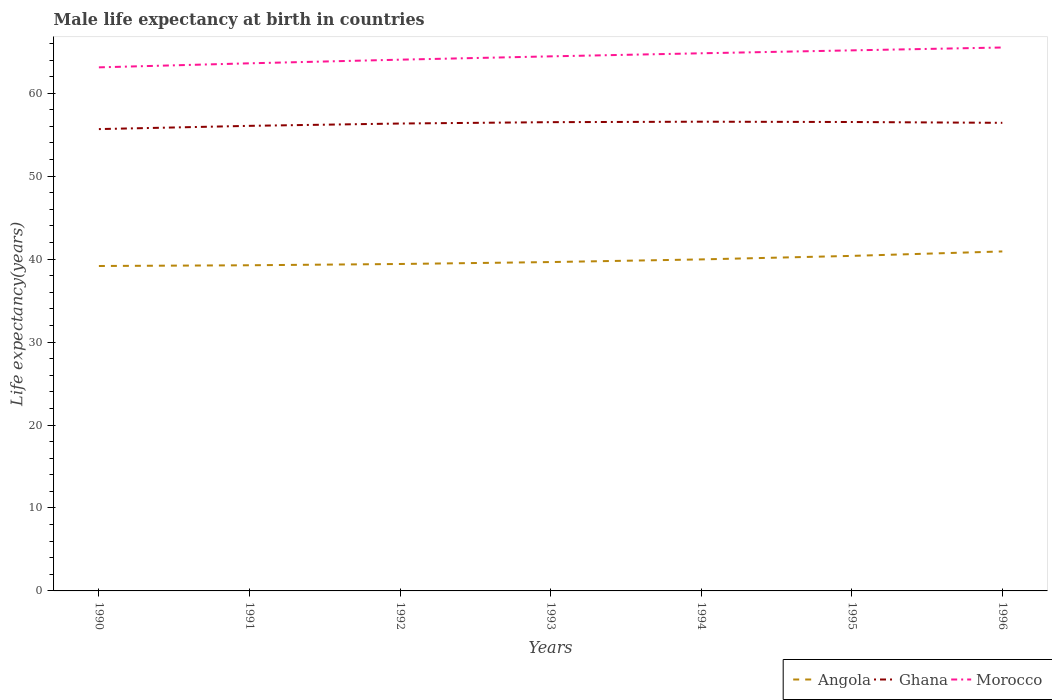Across all years, what is the maximum male life expectancy at birth in Ghana?
Ensure brevity in your answer.  55.68. In which year was the male life expectancy at birth in Ghana maximum?
Your response must be concise. 1990. What is the total male life expectancy at birth in Morocco in the graph?
Make the answer very short. -2.05. What is the difference between the highest and the second highest male life expectancy at birth in Ghana?
Keep it short and to the point. 0.89. Is the male life expectancy at birth in Morocco strictly greater than the male life expectancy at birth in Angola over the years?
Offer a terse response. No. How many years are there in the graph?
Make the answer very short. 7. What is the difference between two consecutive major ticks on the Y-axis?
Keep it short and to the point. 10. Does the graph contain grids?
Give a very brief answer. No. What is the title of the graph?
Offer a terse response. Male life expectancy at birth in countries. Does "Liberia" appear as one of the legend labels in the graph?
Give a very brief answer. No. What is the label or title of the X-axis?
Offer a very short reply. Years. What is the label or title of the Y-axis?
Your response must be concise. Life expectancy(years). What is the Life expectancy(years) in Angola in 1990?
Your answer should be very brief. 39.17. What is the Life expectancy(years) in Ghana in 1990?
Give a very brief answer. 55.68. What is the Life expectancy(years) of Morocco in 1990?
Provide a short and direct response. 63.12. What is the Life expectancy(years) in Angola in 1991?
Ensure brevity in your answer.  39.26. What is the Life expectancy(years) in Ghana in 1991?
Provide a succinct answer. 56.07. What is the Life expectancy(years) in Morocco in 1991?
Your response must be concise. 63.61. What is the Life expectancy(years) in Angola in 1992?
Your answer should be very brief. 39.41. What is the Life expectancy(years) in Ghana in 1992?
Your response must be concise. 56.35. What is the Life expectancy(years) of Morocco in 1992?
Make the answer very short. 64.05. What is the Life expectancy(years) of Angola in 1993?
Make the answer very short. 39.65. What is the Life expectancy(years) in Ghana in 1993?
Give a very brief answer. 56.51. What is the Life expectancy(years) in Morocco in 1993?
Your answer should be compact. 64.45. What is the Life expectancy(years) of Angola in 1994?
Provide a short and direct response. 39.97. What is the Life expectancy(years) in Ghana in 1994?
Provide a short and direct response. 56.57. What is the Life expectancy(years) of Morocco in 1994?
Ensure brevity in your answer.  64.82. What is the Life expectancy(years) of Angola in 1995?
Ensure brevity in your answer.  40.39. What is the Life expectancy(years) in Ghana in 1995?
Give a very brief answer. 56.53. What is the Life expectancy(years) of Morocco in 1995?
Offer a terse response. 65.17. What is the Life expectancy(years) in Angola in 1996?
Keep it short and to the point. 40.93. What is the Life expectancy(years) in Ghana in 1996?
Your response must be concise. 56.43. What is the Life expectancy(years) in Morocco in 1996?
Your response must be concise. 65.51. Across all years, what is the maximum Life expectancy(years) of Angola?
Offer a terse response. 40.93. Across all years, what is the maximum Life expectancy(years) in Ghana?
Make the answer very short. 56.57. Across all years, what is the maximum Life expectancy(years) of Morocco?
Ensure brevity in your answer.  65.51. Across all years, what is the minimum Life expectancy(years) of Angola?
Your answer should be compact. 39.17. Across all years, what is the minimum Life expectancy(years) of Ghana?
Offer a terse response. 55.68. Across all years, what is the minimum Life expectancy(years) in Morocco?
Your answer should be very brief. 63.12. What is the total Life expectancy(years) of Angola in the graph?
Make the answer very short. 278.77. What is the total Life expectancy(years) of Ghana in the graph?
Make the answer very short. 394.14. What is the total Life expectancy(years) of Morocco in the graph?
Give a very brief answer. 450.71. What is the difference between the Life expectancy(years) of Angola in 1990 and that in 1991?
Your response must be concise. -0.09. What is the difference between the Life expectancy(years) of Ghana in 1990 and that in 1991?
Offer a very short reply. -0.39. What is the difference between the Life expectancy(years) in Morocco in 1990 and that in 1991?
Provide a succinct answer. -0.49. What is the difference between the Life expectancy(years) of Angola in 1990 and that in 1992?
Provide a short and direct response. -0.24. What is the difference between the Life expectancy(years) of Ghana in 1990 and that in 1992?
Your answer should be compact. -0.67. What is the difference between the Life expectancy(years) in Morocco in 1990 and that in 1992?
Provide a succinct answer. -0.93. What is the difference between the Life expectancy(years) of Angola in 1990 and that in 1993?
Offer a terse response. -0.47. What is the difference between the Life expectancy(years) in Ghana in 1990 and that in 1993?
Provide a succinct answer. -0.83. What is the difference between the Life expectancy(years) in Morocco in 1990 and that in 1993?
Provide a succinct answer. -1.33. What is the difference between the Life expectancy(years) of Angola in 1990 and that in 1994?
Your response must be concise. -0.79. What is the difference between the Life expectancy(years) of Ghana in 1990 and that in 1994?
Make the answer very short. -0.89. What is the difference between the Life expectancy(years) in Morocco in 1990 and that in 1994?
Your response must be concise. -1.7. What is the difference between the Life expectancy(years) in Angola in 1990 and that in 1995?
Your response must be concise. -1.22. What is the difference between the Life expectancy(years) of Ghana in 1990 and that in 1995?
Ensure brevity in your answer.  -0.85. What is the difference between the Life expectancy(years) in Morocco in 1990 and that in 1995?
Keep it short and to the point. -2.05. What is the difference between the Life expectancy(years) of Angola in 1990 and that in 1996?
Make the answer very short. -1.75. What is the difference between the Life expectancy(years) in Ghana in 1990 and that in 1996?
Your answer should be very brief. -0.76. What is the difference between the Life expectancy(years) in Morocco in 1990 and that in 1996?
Make the answer very short. -2.39. What is the difference between the Life expectancy(years) of Angola in 1991 and that in 1992?
Offer a very short reply. -0.15. What is the difference between the Life expectancy(years) in Ghana in 1991 and that in 1992?
Your answer should be very brief. -0.28. What is the difference between the Life expectancy(years) in Morocco in 1991 and that in 1992?
Provide a short and direct response. -0.44. What is the difference between the Life expectancy(years) in Angola in 1991 and that in 1993?
Provide a short and direct response. -0.39. What is the difference between the Life expectancy(years) in Ghana in 1991 and that in 1993?
Offer a terse response. -0.44. What is the difference between the Life expectancy(years) of Morocco in 1991 and that in 1993?
Ensure brevity in your answer.  -0.84. What is the difference between the Life expectancy(years) of Angola in 1991 and that in 1994?
Provide a succinct answer. -0.71. What is the difference between the Life expectancy(years) of Morocco in 1991 and that in 1994?
Your response must be concise. -1.21. What is the difference between the Life expectancy(years) of Angola in 1991 and that in 1995?
Provide a succinct answer. -1.13. What is the difference between the Life expectancy(years) in Ghana in 1991 and that in 1995?
Give a very brief answer. -0.46. What is the difference between the Life expectancy(years) of Morocco in 1991 and that in 1995?
Your answer should be very brief. -1.56. What is the difference between the Life expectancy(years) of Angola in 1991 and that in 1996?
Ensure brevity in your answer.  -1.67. What is the difference between the Life expectancy(years) of Ghana in 1991 and that in 1996?
Provide a succinct answer. -0.36. What is the difference between the Life expectancy(years) in Morocco in 1991 and that in 1996?
Your response must be concise. -1.91. What is the difference between the Life expectancy(years) of Angola in 1992 and that in 1993?
Your answer should be very brief. -0.23. What is the difference between the Life expectancy(years) in Ghana in 1992 and that in 1993?
Your response must be concise. -0.16. What is the difference between the Life expectancy(years) in Morocco in 1992 and that in 1993?
Your response must be concise. -0.4. What is the difference between the Life expectancy(years) of Angola in 1992 and that in 1994?
Keep it short and to the point. -0.55. What is the difference between the Life expectancy(years) of Ghana in 1992 and that in 1994?
Keep it short and to the point. -0.22. What is the difference between the Life expectancy(years) in Morocco in 1992 and that in 1994?
Offer a very short reply. -0.77. What is the difference between the Life expectancy(years) in Angola in 1992 and that in 1995?
Offer a very short reply. -0.98. What is the difference between the Life expectancy(years) of Ghana in 1992 and that in 1995?
Ensure brevity in your answer.  -0.18. What is the difference between the Life expectancy(years) in Morocco in 1992 and that in 1995?
Your answer should be very brief. -1.12. What is the difference between the Life expectancy(years) of Angola in 1992 and that in 1996?
Make the answer very short. -1.51. What is the difference between the Life expectancy(years) of Ghana in 1992 and that in 1996?
Your answer should be very brief. -0.08. What is the difference between the Life expectancy(years) of Morocco in 1992 and that in 1996?
Make the answer very short. -1.47. What is the difference between the Life expectancy(years) of Angola in 1993 and that in 1994?
Offer a very short reply. -0.32. What is the difference between the Life expectancy(years) of Ghana in 1993 and that in 1994?
Make the answer very short. -0.06. What is the difference between the Life expectancy(years) in Morocco in 1993 and that in 1994?
Your answer should be very brief. -0.37. What is the difference between the Life expectancy(years) in Angola in 1993 and that in 1995?
Provide a short and direct response. -0.74. What is the difference between the Life expectancy(years) of Ghana in 1993 and that in 1995?
Your answer should be very brief. -0.02. What is the difference between the Life expectancy(years) in Morocco in 1993 and that in 1995?
Provide a short and direct response. -0.72. What is the difference between the Life expectancy(years) in Angola in 1993 and that in 1996?
Your response must be concise. -1.28. What is the difference between the Life expectancy(years) of Ghana in 1993 and that in 1996?
Make the answer very short. 0.08. What is the difference between the Life expectancy(years) in Morocco in 1993 and that in 1996?
Provide a short and direct response. -1.07. What is the difference between the Life expectancy(years) of Angola in 1994 and that in 1995?
Your answer should be very brief. -0.42. What is the difference between the Life expectancy(years) in Ghana in 1994 and that in 1995?
Make the answer very short. 0.04. What is the difference between the Life expectancy(years) in Morocco in 1994 and that in 1995?
Provide a short and direct response. -0.35. What is the difference between the Life expectancy(years) of Angola in 1994 and that in 1996?
Provide a succinct answer. -0.96. What is the difference between the Life expectancy(years) in Ghana in 1994 and that in 1996?
Keep it short and to the point. 0.14. What is the difference between the Life expectancy(years) of Morocco in 1994 and that in 1996?
Provide a succinct answer. -0.7. What is the difference between the Life expectancy(years) of Angola in 1995 and that in 1996?
Your response must be concise. -0.54. What is the difference between the Life expectancy(years) of Ghana in 1995 and that in 1996?
Keep it short and to the point. 0.1. What is the difference between the Life expectancy(years) in Morocco in 1995 and that in 1996?
Ensure brevity in your answer.  -0.34. What is the difference between the Life expectancy(years) in Angola in 1990 and the Life expectancy(years) in Ghana in 1991?
Provide a short and direct response. -16.9. What is the difference between the Life expectancy(years) of Angola in 1990 and the Life expectancy(years) of Morocco in 1991?
Your response must be concise. -24.43. What is the difference between the Life expectancy(years) in Ghana in 1990 and the Life expectancy(years) in Morocco in 1991?
Your response must be concise. -7.93. What is the difference between the Life expectancy(years) in Angola in 1990 and the Life expectancy(years) in Ghana in 1992?
Offer a terse response. -17.18. What is the difference between the Life expectancy(years) of Angola in 1990 and the Life expectancy(years) of Morocco in 1992?
Provide a short and direct response. -24.87. What is the difference between the Life expectancy(years) in Ghana in 1990 and the Life expectancy(years) in Morocco in 1992?
Offer a terse response. -8.37. What is the difference between the Life expectancy(years) in Angola in 1990 and the Life expectancy(years) in Ghana in 1993?
Provide a short and direct response. -17.34. What is the difference between the Life expectancy(years) in Angola in 1990 and the Life expectancy(years) in Morocco in 1993?
Keep it short and to the point. -25.27. What is the difference between the Life expectancy(years) of Ghana in 1990 and the Life expectancy(years) of Morocco in 1993?
Your answer should be very brief. -8.77. What is the difference between the Life expectancy(years) of Angola in 1990 and the Life expectancy(years) of Ghana in 1994?
Give a very brief answer. -17.4. What is the difference between the Life expectancy(years) of Angola in 1990 and the Life expectancy(years) of Morocco in 1994?
Provide a short and direct response. -25.64. What is the difference between the Life expectancy(years) in Ghana in 1990 and the Life expectancy(years) in Morocco in 1994?
Your answer should be very brief. -9.14. What is the difference between the Life expectancy(years) of Angola in 1990 and the Life expectancy(years) of Ghana in 1995?
Make the answer very short. -17.36. What is the difference between the Life expectancy(years) in Angola in 1990 and the Life expectancy(years) in Morocco in 1995?
Your answer should be compact. -26. What is the difference between the Life expectancy(years) of Ghana in 1990 and the Life expectancy(years) of Morocco in 1995?
Make the answer very short. -9.49. What is the difference between the Life expectancy(years) of Angola in 1990 and the Life expectancy(years) of Ghana in 1996?
Your response must be concise. -17.26. What is the difference between the Life expectancy(years) of Angola in 1990 and the Life expectancy(years) of Morocco in 1996?
Provide a short and direct response. -26.34. What is the difference between the Life expectancy(years) in Ghana in 1990 and the Life expectancy(years) in Morocco in 1996?
Provide a short and direct response. -9.84. What is the difference between the Life expectancy(years) in Angola in 1991 and the Life expectancy(years) in Ghana in 1992?
Make the answer very short. -17.09. What is the difference between the Life expectancy(years) in Angola in 1991 and the Life expectancy(years) in Morocco in 1992?
Give a very brief answer. -24.79. What is the difference between the Life expectancy(years) of Ghana in 1991 and the Life expectancy(years) of Morocco in 1992?
Make the answer very short. -7.98. What is the difference between the Life expectancy(years) of Angola in 1991 and the Life expectancy(years) of Ghana in 1993?
Your response must be concise. -17.25. What is the difference between the Life expectancy(years) in Angola in 1991 and the Life expectancy(years) in Morocco in 1993?
Provide a short and direct response. -25.19. What is the difference between the Life expectancy(years) of Ghana in 1991 and the Life expectancy(years) of Morocco in 1993?
Offer a terse response. -8.38. What is the difference between the Life expectancy(years) of Angola in 1991 and the Life expectancy(years) of Ghana in 1994?
Ensure brevity in your answer.  -17.31. What is the difference between the Life expectancy(years) of Angola in 1991 and the Life expectancy(years) of Morocco in 1994?
Your answer should be compact. -25.56. What is the difference between the Life expectancy(years) of Ghana in 1991 and the Life expectancy(years) of Morocco in 1994?
Keep it short and to the point. -8.75. What is the difference between the Life expectancy(years) of Angola in 1991 and the Life expectancy(years) of Ghana in 1995?
Offer a terse response. -17.27. What is the difference between the Life expectancy(years) of Angola in 1991 and the Life expectancy(years) of Morocco in 1995?
Provide a short and direct response. -25.91. What is the difference between the Life expectancy(years) in Angola in 1991 and the Life expectancy(years) in Ghana in 1996?
Provide a succinct answer. -17.17. What is the difference between the Life expectancy(years) in Angola in 1991 and the Life expectancy(years) in Morocco in 1996?
Your answer should be compact. -26.25. What is the difference between the Life expectancy(years) of Ghana in 1991 and the Life expectancy(years) of Morocco in 1996?
Provide a succinct answer. -9.45. What is the difference between the Life expectancy(years) in Angola in 1992 and the Life expectancy(years) in Ghana in 1993?
Offer a terse response. -17.1. What is the difference between the Life expectancy(years) in Angola in 1992 and the Life expectancy(years) in Morocco in 1993?
Make the answer very short. -25.03. What is the difference between the Life expectancy(years) in Ghana in 1992 and the Life expectancy(years) in Morocco in 1993?
Provide a short and direct response. -8.1. What is the difference between the Life expectancy(years) in Angola in 1992 and the Life expectancy(years) in Ghana in 1994?
Your answer should be very brief. -17.15. What is the difference between the Life expectancy(years) in Angola in 1992 and the Life expectancy(years) in Morocco in 1994?
Make the answer very short. -25.4. What is the difference between the Life expectancy(years) in Ghana in 1992 and the Life expectancy(years) in Morocco in 1994?
Make the answer very short. -8.47. What is the difference between the Life expectancy(years) in Angola in 1992 and the Life expectancy(years) in Ghana in 1995?
Ensure brevity in your answer.  -17.12. What is the difference between the Life expectancy(years) of Angola in 1992 and the Life expectancy(years) of Morocco in 1995?
Your answer should be very brief. -25.75. What is the difference between the Life expectancy(years) of Ghana in 1992 and the Life expectancy(years) of Morocco in 1995?
Provide a short and direct response. -8.82. What is the difference between the Life expectancy(years) in Angola in 1992 and the Life expectancy(years) in Ghana in 1996?
Your answer should be compact. -17.02. What is the difference between the Life expectancy(years) of Angola in 1992 and the Life expectancy(years) of Morocco in 1996?
Offer a terse response. -26.1. What is the difference between the Life expectancy(years) of Ghana in 1992 and the Life expectancy(years) of Morocco in 1996?
Make the answer very short. -9.16. What is the difference between the Life expectancy(years) in Angola in 1993 and the Life expectancy(years) in Ghana in 1994?
Your answer should be very brief. -16.92. What is the difference between the Life expectancy(years) of Angola in 1993 and the Life expectancy(years) of Morocco in 1994?
Your answer should be compact. -25.17. What is the difference between the Life expectancy(years) of Ghana in 1993 and the Life expectancy(years) of Morocco in 1994?
Make the answer very short. -8.3. What is the difference between the Life expectancy(years) in Angola in 1993 and the Life expectancy(years) in Ghana in 1995?
Make the answer very short. -16.89. What is the difference between the Life expectancy(years) of Angola in 1993 and the Life expectancy(years) of Morocco in 1995?
Provide a succinct answer. -25.52. What is the difference between the Life expectancy(years) of Ghana in 1993 and the Life expectancy(years) of Morocco in 1995?
Your answer should be very brief. -8.66. What is the difference between the Life expectancy(years) in Angola in 1993 and the Life expectancy(years) in Ghana in 1996?
Offer a very short reply. -16.79. What is the difference between the Life expectancy(years) of Angola in 1993 and the Life expectancy(years) of Morocco in 1996?
Make the answer very short. -25.87. What is the difference between the Life expectancy(years) in Ghana in 1993 and the Life expectancy(years) in Morocco in 1996?
Your response must be concise. -9. What is the difference between the Life expectancy(years) of Angola in 1994 and the Life expectancy(years) of Ghana in 1995?
Your answer should be compact. -16.57. What is the difference between the Life expectancy(years) of Angola in 1994 and the Life expectancy(years) of Morocco in 1995?
Make the answer very short. -25.2. What is the difference between the Life expectancy(years) in Ghana in 1994 and the Life expectancy(years) in Morocco in 1995?
Give a very brief answer. -8.6. What is the difference between the Life expectancy(years) of Angola in 1994 and the Life expectancy(years) of Ghana in 1996?
Make the answer very short. -16.47. What is the difference between the Life expectancy(years) of Angola in 1994 and the Life expectancy(years) of Morocco in 1996?
Provide a succinct answer. -25.55. What is the difference between the Life expectancy(years) of Ghana in 1994 and the Life expectancy(years) of Morocco in 1996?
Your response must be concise. -8.95. What is the difference between the Life expectancy(years) in Angola in 1995 and the Life expectancy(years) in Ghana in 1996?
Your answer should be compact. -16.04. What is the difference between the Life expectancy(years) in Angola in 1995 and the Life expectancy(years) in Morocco in 1996?
Provide a short and direct response. -25.12. What is the difference between the Life expectancy(years) of Ghana in 1995 and the Life expectancy(years) of Morocco in 1996?
Keep it short and to the point. -8.98. What is the average Life expectancy(years) in Angola per year?
Your response must be concise. 39.83. What is the average Life expectancy(years) in Ghana per year?
Give a very brief answer. 56.31. What is the average Life expectancy(years) of Morocco per year?
Give a very brief answer. 64.39. In the year 1990, what is the difference between the Life expectancy(years) in Angola and Life expectancy(years) in Ghana?
Provide a short and direct response. -16.5. In the year 1990, what is the difference between the Life expectancy(years) of Angola and Life expectancy(years) of Morocco?
Make the answer very short. -23.95. In the year 1990, what is the difference between the Life expectancy(years) in Ghana and Life expectancy(years) in Morocco?
Your answer should be compact. -7.44. In the year 1991, what is the difference between the Life expectancy(years) of Angola and Life expectancy(years) of Ghana?
Offer a terse response. -16.81. In the year 1991, what is the difference between the Life expectancy(years) of Angola and Life expectancy(years) of Morocco?
Your response must be concise. -24.35. In the year 1991, what is the difference between the Life expectancy(years) of Ghana and Life expectancy(years) of Morocco?
Give a very brief answer. -7.54. In the year 1992, what is the difference between the Life expectancy(years) of Angola and Life expectancy(years) of Ghana?
Make the answer very short. -16.93. In the year 1992, what is the difference between the Life expectancy(years) of Angola and Life expectancy(years) of Morocco?
Make the answer very short. -24.63. In the year 1992, what is the difference between the Life expectancy(years) in Ghana and Life expectancy(years) in Morocco?
Offer a terse response. -7.7. In the year 1993, what is the difference between the Life expectancy(years) in Angola and Life expectancy(years) in Ghana?
Ensure brevity in your answer.  -16.87. In the year 1993, what is the difference between the Life expectancy(years) of Angola and Life expectancy(years) of Morocco?
Your response must be concise. -24.8. In the year 1993, what is the difference between the Life expectancy(years) in Ghana and Life expectancy(years) in Morocco?
Provide a short and direct response. -7.93. In the year 1994, what is the difference between the Life expectancy(years) in Angola and Life expectancy(years) in Ghana?
Ensure brevity in your answer.  -16.6. In the year 1994, what is the difference between the Life expectancy(years) in Angola and Life expectancy(years) in Morocco?
Your answer should be very brief. -24.85. In the year 1994, what is the difference between the Life expectancy(years) in Ghana and Life expectancy(years) in Morocco?
Offer a terse response. -8.25. In the year 1995, what is the difference between the Life expectancy(years) in Angola and Life expectancy(years) in Ghana?
Give a very brief answer. -16.14. In the year 1995, what is the difference between the Life expectancy(years) of Angola and Life expectancy(years) of Morocco?
Your response must be concise. -24.78. In the year 1995, what is the difference between the Life expectancy(years) in Ghana and Life expectancy(years) in Morocco?
Provide a short and direct response. -8.64. In the year 1996, what is the difference between the Life expectancy(years) in Angola and Life expectancy(years) in Ghana?
Your answer should be very brief. -15.51. In the year 1996, what is the difference between the Life expectancy(years) in Angola and Life expectancy(years) in Morocco?
Offer a very short reply. -24.59. In the year 1996, what is the difference between the Life expectancy(years) in Ghana and Life expectancy(years) in Morocco?
Make the answer very short. -9.08. What is the ratio of the Life expectancy(years) in Morocco in 1990 to that in 1991?
Keep it short and to the point. 0.99. What is the ratio of the Life expectancy(years) of Ghana in 1990 to that in 1992?
Provide a short and direct response. 0.99. What is the ratio of the Life expectancy(years) of Morocco in 1990 to that in 1992?
Provide a short and direct response. 0.99. What is the ratio of the Life expectancy(years) of Angola in 1990 to that in 1993?
Offer a very short reply. 0.99. What is the ratio of the Life expectancy(years) in Ghana in 1990 to that in 1993?
Keep it short and to the point. 0.99. What is the ratio of the Life expectancy(years) of Morocco in 1990 to that in 1993?
Your answer should be very brief. 0.98. What is the ratio of the Life expectancy(years) in Angola in 1990 to that in 1994?
Provide a short and direct response. 0.98. What is the ratio of the Life expectancy(years) in Ghana in 1990 to that in 1994?
Your answer should be very brief. 0.98. What is the ratio of the Life expectancy(years) in Morocco in 1990 to that in 1994?
Your answer should be compact. 0.97. What is the ratio of the Life expectancy(years) in Angola in 1990 to that in 1995?
Offer a very short reply. 0.97. What is the ratio of the Life expectancy(years) in Ghana in 1990 to that in 1995?
Give a very brief answer. 0.98. What is the ratio of the Life expectancy(years) in Morocco in 1990 to that in 1995?
Give a very brief answer. 0.97. What is the ratio of the Life expectancy(years) of Angola in 1990 to that in 1996?
Your answer should be very brief. 0.96. What is the ratio of the Life expectancy(years) of Ghana in 1990 to that in 1996?
Give a very brief answer. 0.99. What is the ratio of the Life expectancy(years) in Morocco in 1990 to that in 1996?
Ensure brevity in your answer.  0.96. What is the ratio of the Life expectancy(years) in Morocco in 1991 to that in 1992?
Ensure brevity in your answer.  0.99. What is the ratio of the Life expectancy(years) in Angola in 1991 to that in 1993?
Ensure brevity in your answer.  0.99. What is the ratio of the Life expectancy(years) of Ghana in 1991 to that in 1993?
Your answer should be very brief. 0.99. What is the ratio of the Life expectancy(years) of Angola in 1991 to that in 1994?
Your answer should be compact. 0.98. What is the ratio of the Life expectancy(years) of Ghana in 1991 to that in 1994?
Provide a short and direct response. 0.99. What is the ratio of the Life expectancy(years) in Morocco in 1991 to that in 1994?
Offer a very short reply. 0.98. What is the ratio of the Life expectancy(years) of Angola in 1991 to that in 1995?
Offer a very short reply. 0.97. What is the ratio of the Life expectancy(years) in Morocco in 1991 to that in 1995?
Keep it short and to the point. 0.98. What is the ratio of the Life expectancy(years) in Angola in 1991 to that in 1996?
Your answer should be very brief. 0.96. What is the ratio of the Life expectancy(years) in Morocco in 1991 to that in 1996?
Make the answer very short. 0.97. What is the ratio of the Life expectancy(years) in Morocco in 1992 to that in 1993?
Offer a terse response. 0.99. What is the ratio of the Life expectancy(years) in Angola in 1992 to that in 1994?
Your answer should be compact. 0.99. What is the ratio of the Life expectancy(years) of Angola in 1992 to that in 1995?
Make the answer very short. 0.98. What is the ratio of the Life expectancy(years) of Morocco in 1992 to that in 1995?
Provide a succinct answer. 0.98. What is the ratio of the Life expectancy(years) in Angola in 1992 to that in 1996?
Provide a succinct answer. 0.96. What is the ratio of the Life expectancy(years) in Morocco in 1992 to that in 1996?
Offer a terse response. 0.98. What is the ratio of the Life expectancy(years) in Angola in 1993 to that in 1994?
Keep it short and to the point. 0.99. What is the ratio of the Life expectancy(years) in Ghana in 1993 to that in 1994?
Offer a very short reply. 1. What is the ratio of the Life expectancy(years) in Morocco in 1993 to that in 1994?
Make the answer very short. 0.99. What is the ratio of the Life expectancy(years) in Angola in 1993 to that in 1995?
Make the answer very short. 0.98. What is the ratio of the Life expectancy(years) in Ghana in 1993 to that in 1995?
Provide a short and direct response. 1. What is the ratio of the Life expectancy(years) of Morocco in 1993 to that in 1995?
Your answer should be compact. 0.99. What is the ratio of the Life expectancy(years) in Angola in 1993 to that in 1996?
Provide a short and direct response. 0.97. What is the ratio of the Life expectancy(years) of Ghana in 1993 to that in 1996?
Make the answer very short. 1. What is the ratio of the Life expectancy(years) in Morocco in 1993 to that in 1996?
Your response must be concise. 0.98. What is the ratio of the Life expectancy(years) in Ghana in 1994 to that in 1995?
Your answer should be very brief. 1. What is the ratio of the Life expectancy(years) in Angola in 1994 to that in 1996?
Keep it short and to the point. 0.98. What is the ratio of the Life expectancy(years) of Morocco in 1994 to that in 1996?
Provide a short and direct response. 0.99. What is the ratio of the Life expectancy(years) in Angola in 1995 to that in 1996?
Your answer should be compact. 0.99. What is the ratio of the Life expectancy(years) in Ghana in 1995 to that in 1996?
Your answer should be compact. 1. What is the ratio of the Life expectancy(years) in Morocco in 1995 to that in 1996?
Provide a short and direct response. 0.99. What is the difference between the highest and the second highest Life expectancy(years) of Angola?
Offer a very short reply. 0.54. What is the difference between the highest and the second highest Life expectancy(years) of Ghana?
Ensure brevity in your answer.  0.04. What is the difference between the highest and the second highest Life expectancy(years) in Morocco?
Your response must be concise. 0.34. What is the difference between the highest and the lowest Life expectancy(years) in Angola?
Provide a succinct answer. 1.75. What is the difference between the highest and the lowest Life expectancy(years) of Ghana?
Keep it short and to the point. 0.89. What is the difference between the highest and the lowest Life expectancy(years) of Morocco?
Provide a short and direct response. 2.39. 